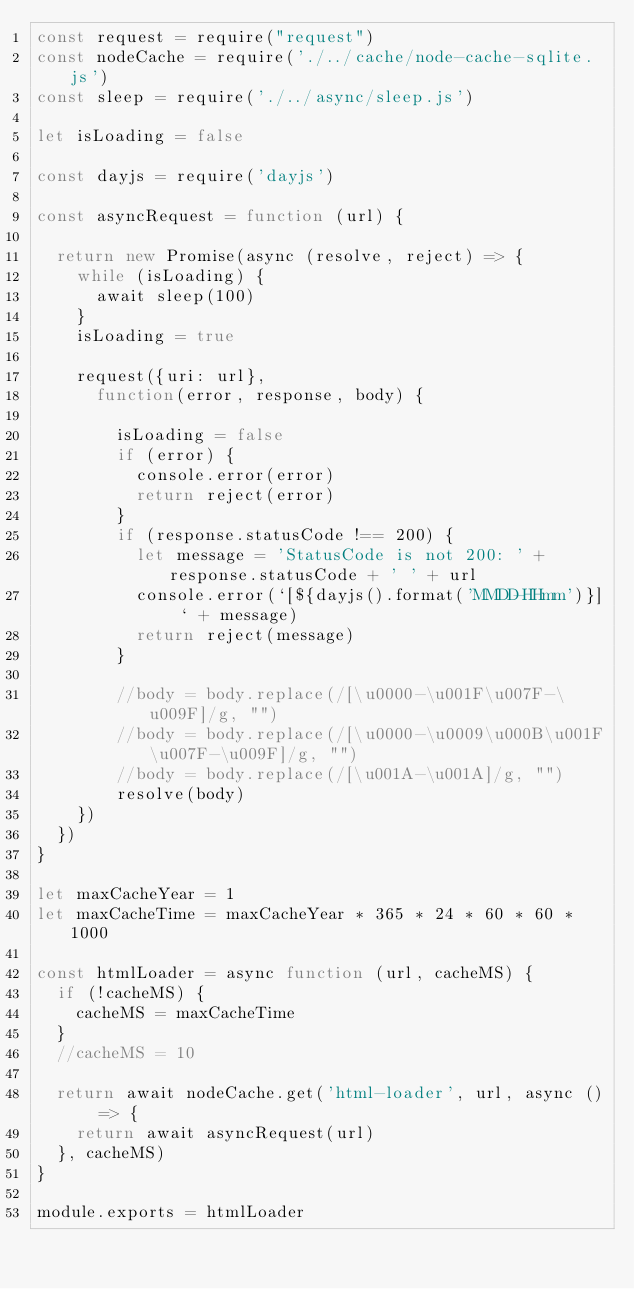Convert code to text. <code><loc_0><loc_0><loc_500><loc_500><_JavaScript_>const request = require("request")
const nodeCache = require('./../cache/node-cache-sqlite.js')
const sleep = require('./../async/sleep.js')

let isLoading = false

const dayjs = require('dayjs')

const asyncRequest = function (url) {
  
  return new Promise(async (resolve, reject) => {
    while (isLoading) {
      await sleep(100)
    }
    isLoading = true
    
    request({uri: url}, 
      function(error, response, body) {
        
        isLoading = false
        if (error) {
          console.error(error)
          return reject(error)
        }
        if (response.statusCode !== 200) {
          let message = 'StatusCode is not 200: ' + response.statusCode + ' ' + url
          console.error(`[${dayjs().format('MMDD-HHmm')}] ` + message)
          return reject(message)
        }

        //body = body.replace(/[\u0000-\u001F\u007F-\u009F]/g, "")
        //body = body.replace(/[\u0000-\u0009\u000B\u001F\u007F-\u009F]/g, "")
        //body = body.replace(/[\u001A-\u001A]/g, "")
        resolve(body)
    })
  })
}

let maxCacheYear = 1
let maxCacheTime = maxCacheYear * 365 * 24 * 60 * 60 * 1000

const htmlLoader = async function (url, cacheMS) {
  if (!cacheMS) {
    cacheMS = maxCacheTime
  }
  //cacheMS = 10
  
  return await nodeCache.get('html-loader', url, async () => {
    return await asyncRequest(url)
  }, cacheMS)
}

module.exports = htmlLoader
  </code> 